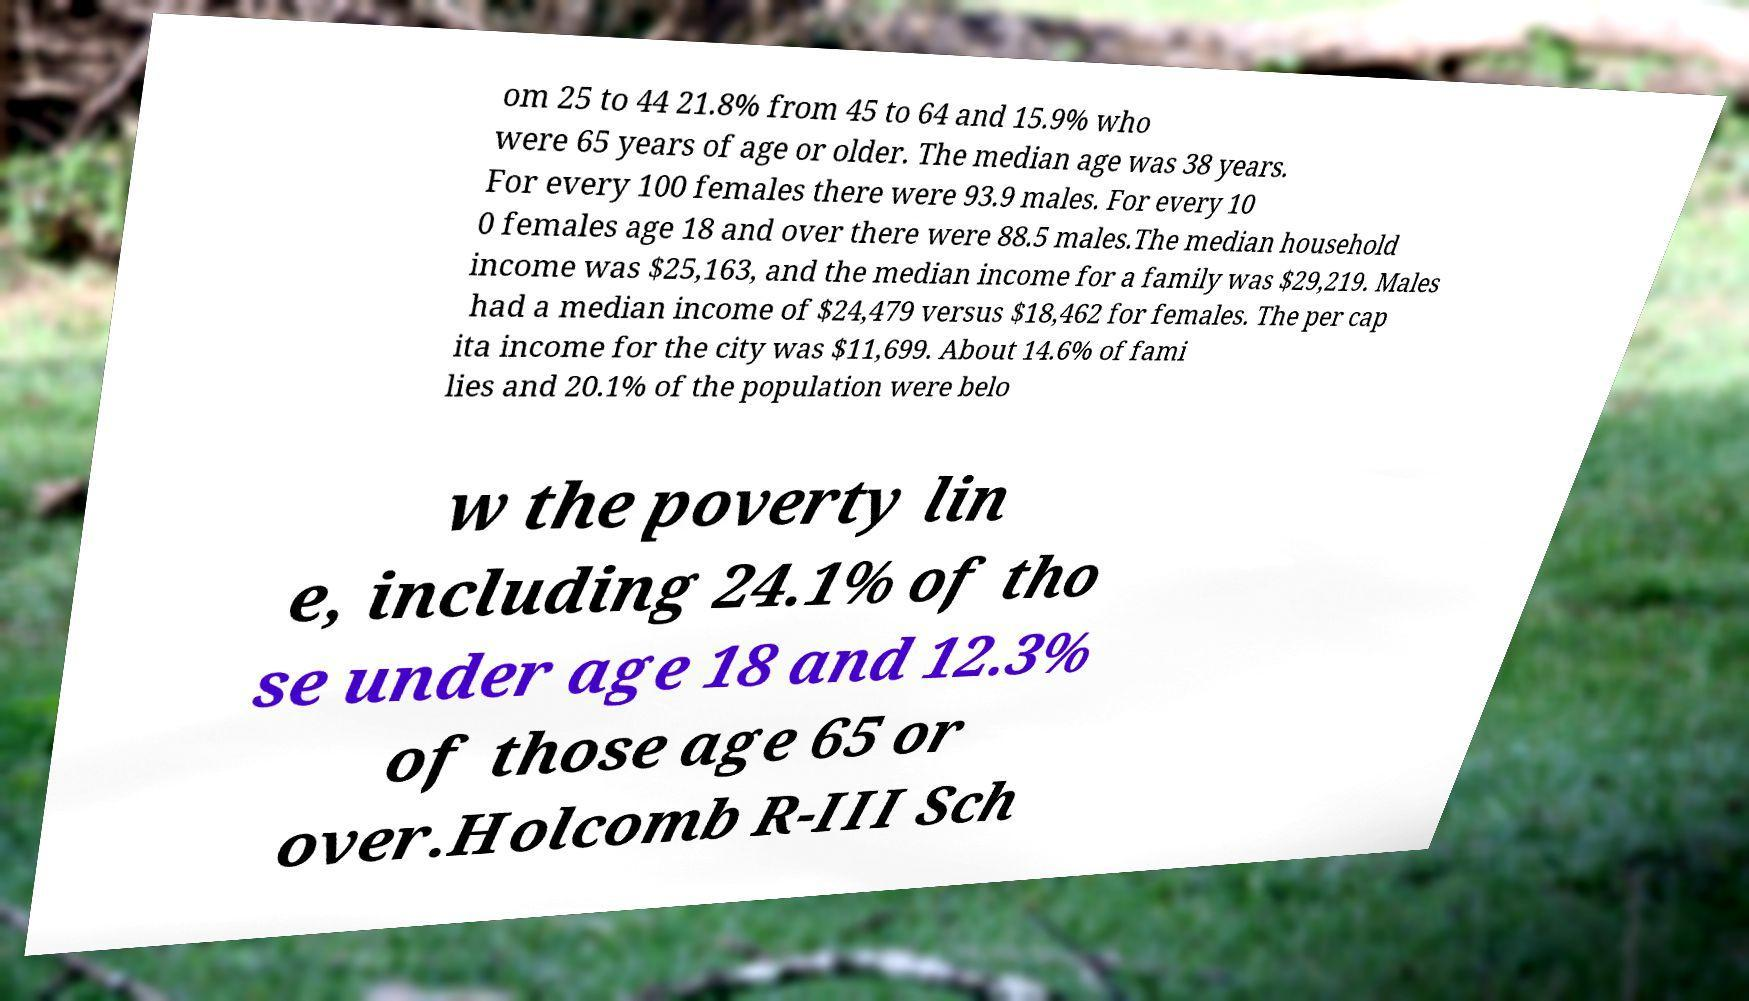Please identify and transcribe the text found in this image. om 25 to 44 21.8% from 45 to 64 and 15.9% who were 65 years of age or older. The median age was 38 years. For every 100 females there were 93.9 males. For every 10 0 females age 18 and over there were 88.5 males.The median household income was $25,163, and the median income for a family was $29,219. Males had a median income of $24,479 versus $18,462 for females. The per cap ita income for the city was $11,699. About 14.6% of fami lies and 20.1% of the population were belo w the poverty lin e, including 24.1% of tho se under age 18 and 12.3% of those age 65 or over.Holcomb R-III Sch 